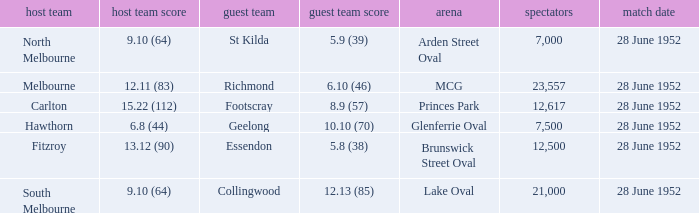What is the home team's score when the venue is princes park? 15.22 (112). 